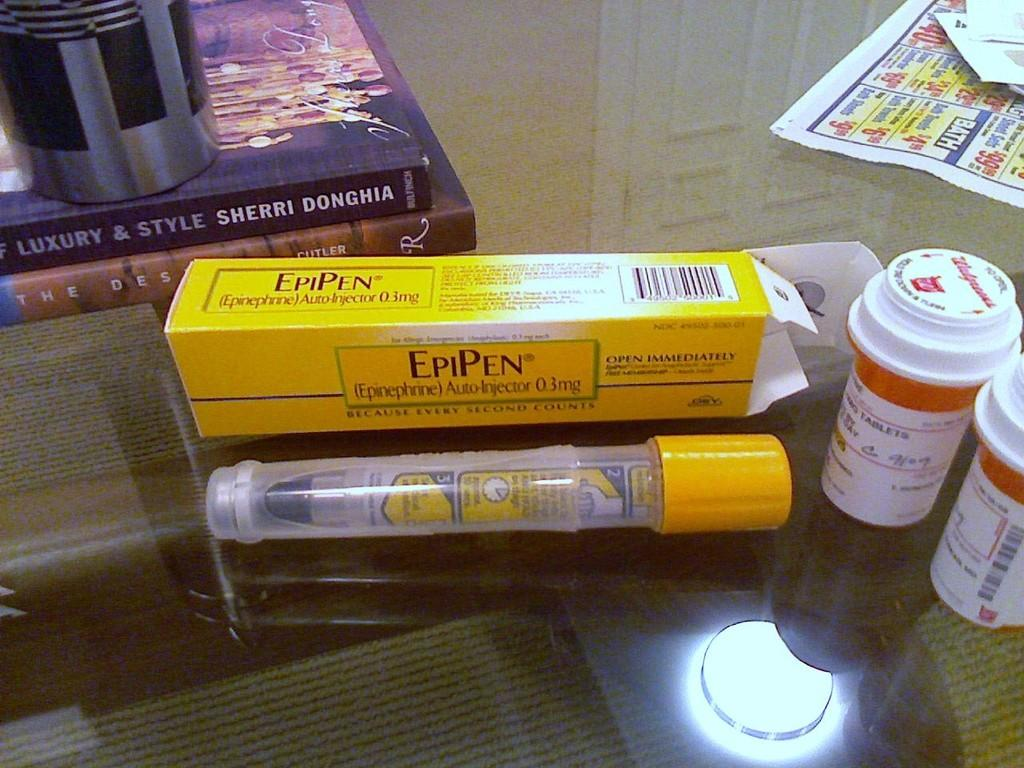Provide a one-sentence caption for the provided image. An EpiPen sitting on top of a glass table with an EpiPen box sitting behind it. 